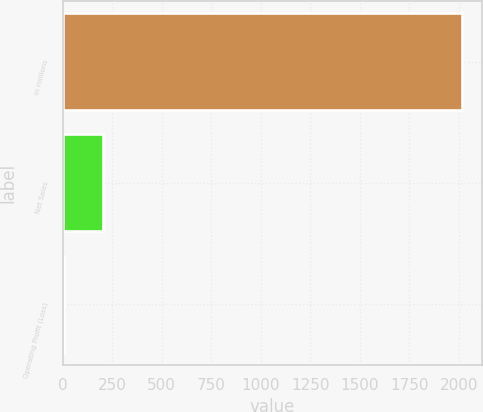Convert chart. <chart><loc_0><loc_0><loc_500><loc_500><bar_chart><fcel>In millions<fcel>Net Sales<fcel>Operating Profit (Loss)<nl><fcel>2017<fcel>206.2<fcel>5<nl></chart> 